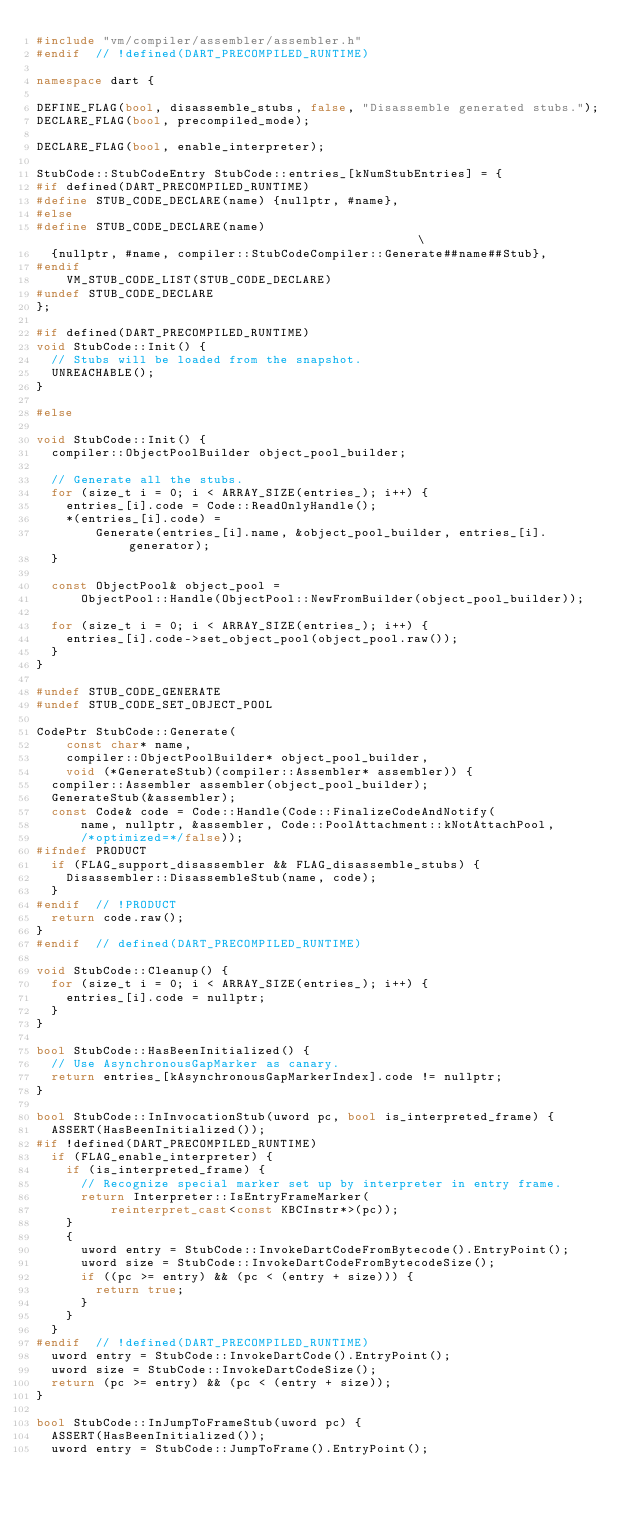<code> <loc_0><loc_0><loc_500><loc_500><_C++_>#include "vm/compiler/assembler/assembler.h"
#endif  // !defined(DART_PRECOMPILED_RUNTIME)

namespace dart {

DEFINE_FLAG(bool, disassemble_stubs, false, "Disassemble generated stubs.");
DECLARE_FLAG(bool, precompiled_mode);

DECLARE_FLAG(bool, enable_interpreter);

StubCode::StubCodeEntry StubCode::entries_[kNumStubEntries] = {
#if defined(DART_PRECOMPILED_RUNTIME)
#define STUB_CODE_DECLARE(name) {nullptr, #name},
#else
#define STUB_CODE_DECLARE(name)                                                \
  {nullptr, #name, compiler::StubCodeCompiler::Generate##name##Stub},
#endif
    VM_STUB_CODE_LIST(STUB_CODE_DECLARE)
#undef STUB_CODE_DECLARE
};

#if defined(DART_PRECOMPILED_RUNTIME)
void StubCode::Init() {
  // Stubs will be loaded from the snapshot.
  UNREACHABLE();
}

#else

void StubCode::Init() {
  compiler::ObjectPoolBuilder object_pool_builder;

  // Generate all the stubs.
  for (size_t i = 0; i < ARRAY_SIZE(entries_); i++) {
    entries_[i].code = Code::ReadOnlyHandle();
    *(entries_[i].code) =
        Generate(entries_[i].name, &object_pool_builder, entries_[i].generator);
  }

  const ObjectPool& object_pool =
      ObjectPool::Handle(ObjectPool::NewFromBuilder(object_pool_builder));

  for (size_t i = 0; i < ARRAY_SIZE(entries_); i++) {
    entries_[i].code->set_object_pool(object_pool.raw());
  }
}

#undef STUB_CODE_GENERATE
#undef STUB_CODE_SET_OBJECT_POOL

CodePtr StubCode::Generate(
    const char* name,
    compiler::ObjectPoolBuilder* object_pool_builder,
    void (*GenerateStub)(compiler::Assembler* assembler)) {
  compiler::Assembler assembler(object_pool_builder);
  GenerateStub(&assembler);
  const Code& code = Code::Handle(Code::FinalizeCodeAndNotify(
      name, nullptr, &assembler, Code::PoolAttachment::kNotAttachPool,
      /*optimized=*/false));
#ifndef PRODUCT
  if (FLAG_support_disassembler && FLAG_disassemble_stubs) {
    Disassembler::DisassembleStub(name, code);
  }
#endif  // !PRODUCT
  return code.raw();
}
#endif  // defined(DART_PRECOMPILED_RUNTIME)

void StubCode::Cleanup() {
  for (size_t i = 0; i < ARRAY_SIZE(entries_); i++) {
    entries_[i].code = nullptr;
  }
}

bool StubCode::HasBeenInitialized() {
  // Use AsynchronousGapMarker as canary.
  return entries_[kAsynchronousGapMarkerIndex].code != nullptr;
}

bool StubCode::InInvocationStub(uword pc, bool is_interpreted_frame) {
  ASSERT(HasBeenInitialized());
#if !defined(DART_PRECOMPILED_RUNTIME)
  if (FLAG_enable_interpreter) {
    if (is_interpreted_frame) {
      // Recognize special marker set up by interpreter in entry frame.
      return Interpreter::IsEntryFrameMarker(
          reinterpret_cast<const KBCInstr*>(pc));
    }
    {
      uword entry = StubCode::InvokeDartCodeFromBytecode().EntryPoint();
      uword size = StubCode::InvokeDartCodeFromBytecodeSize();
      if ((pc >= entry) && (pc < (entry + size))) {
        return true;
      }
    }
  }
#endif  // !defined(DART_PRECOMPILED_RUNTIME)
  uword entry = StubCode::InvokeDartCode().EntryPoint();
  uword size = StubCode::InvokeDartCodeSize();
  return (pc >= entry) && (pc < (entry + size));
}

bool StubCode::InJumpToFrameStub(uword pc) {
  ASSERT(HasBeenInitialized());
  uword entry = StubCode::JumpToFrame().EntryPoint();</code> 